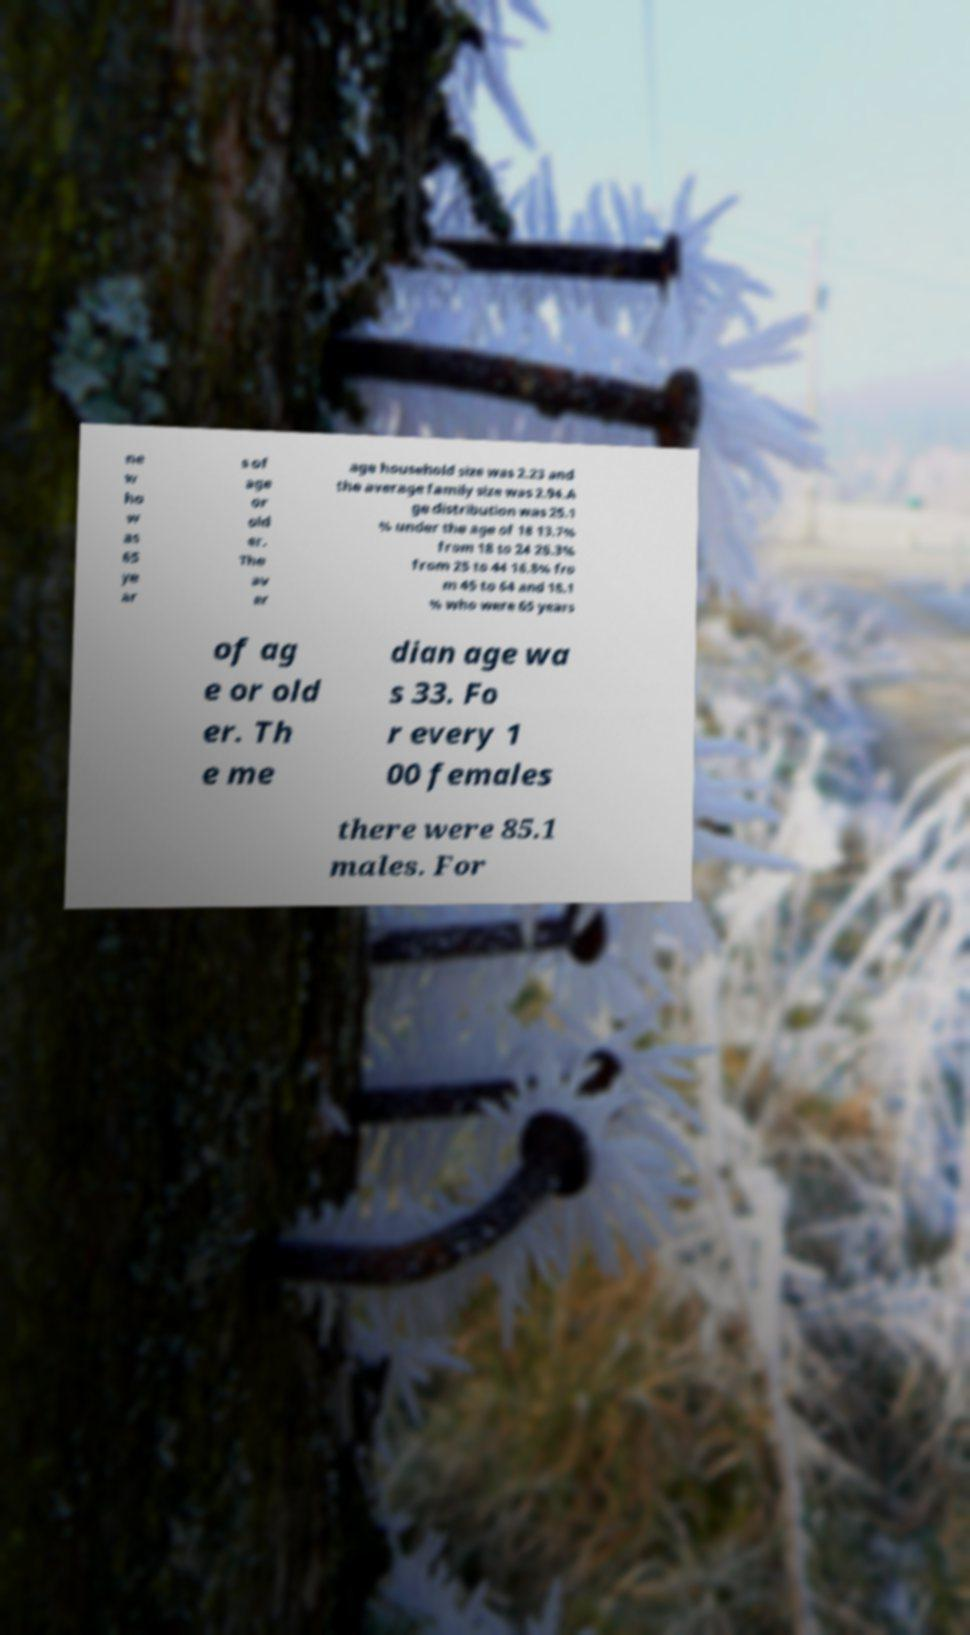What messages or text are displayed in this image? I need them in a readable, typed format. ne w ho w as 65 ye ar s of age or old er. The av er age household size was 2.23 and the average family size was 2.94.A ge distribution was 25.1 % under the age of 18 13.7% from 18 to 24 26.3% from 25 to 44 16.8% fro m 45 to 64 and 18.1 % who were 65 years of ag e or old er. Th e me dian age wa s 33. Fo r every 1 00 females there were 85.1 males. For 